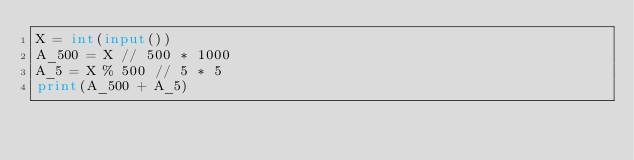<code> <loc_0><loc_0><loc_500><loc_500><_Python_>X = int(input())
A_500 = X // 500 * 1000
A_5 = X % 500 // 5 * 5
print(A_500 + A_5)
</code> 